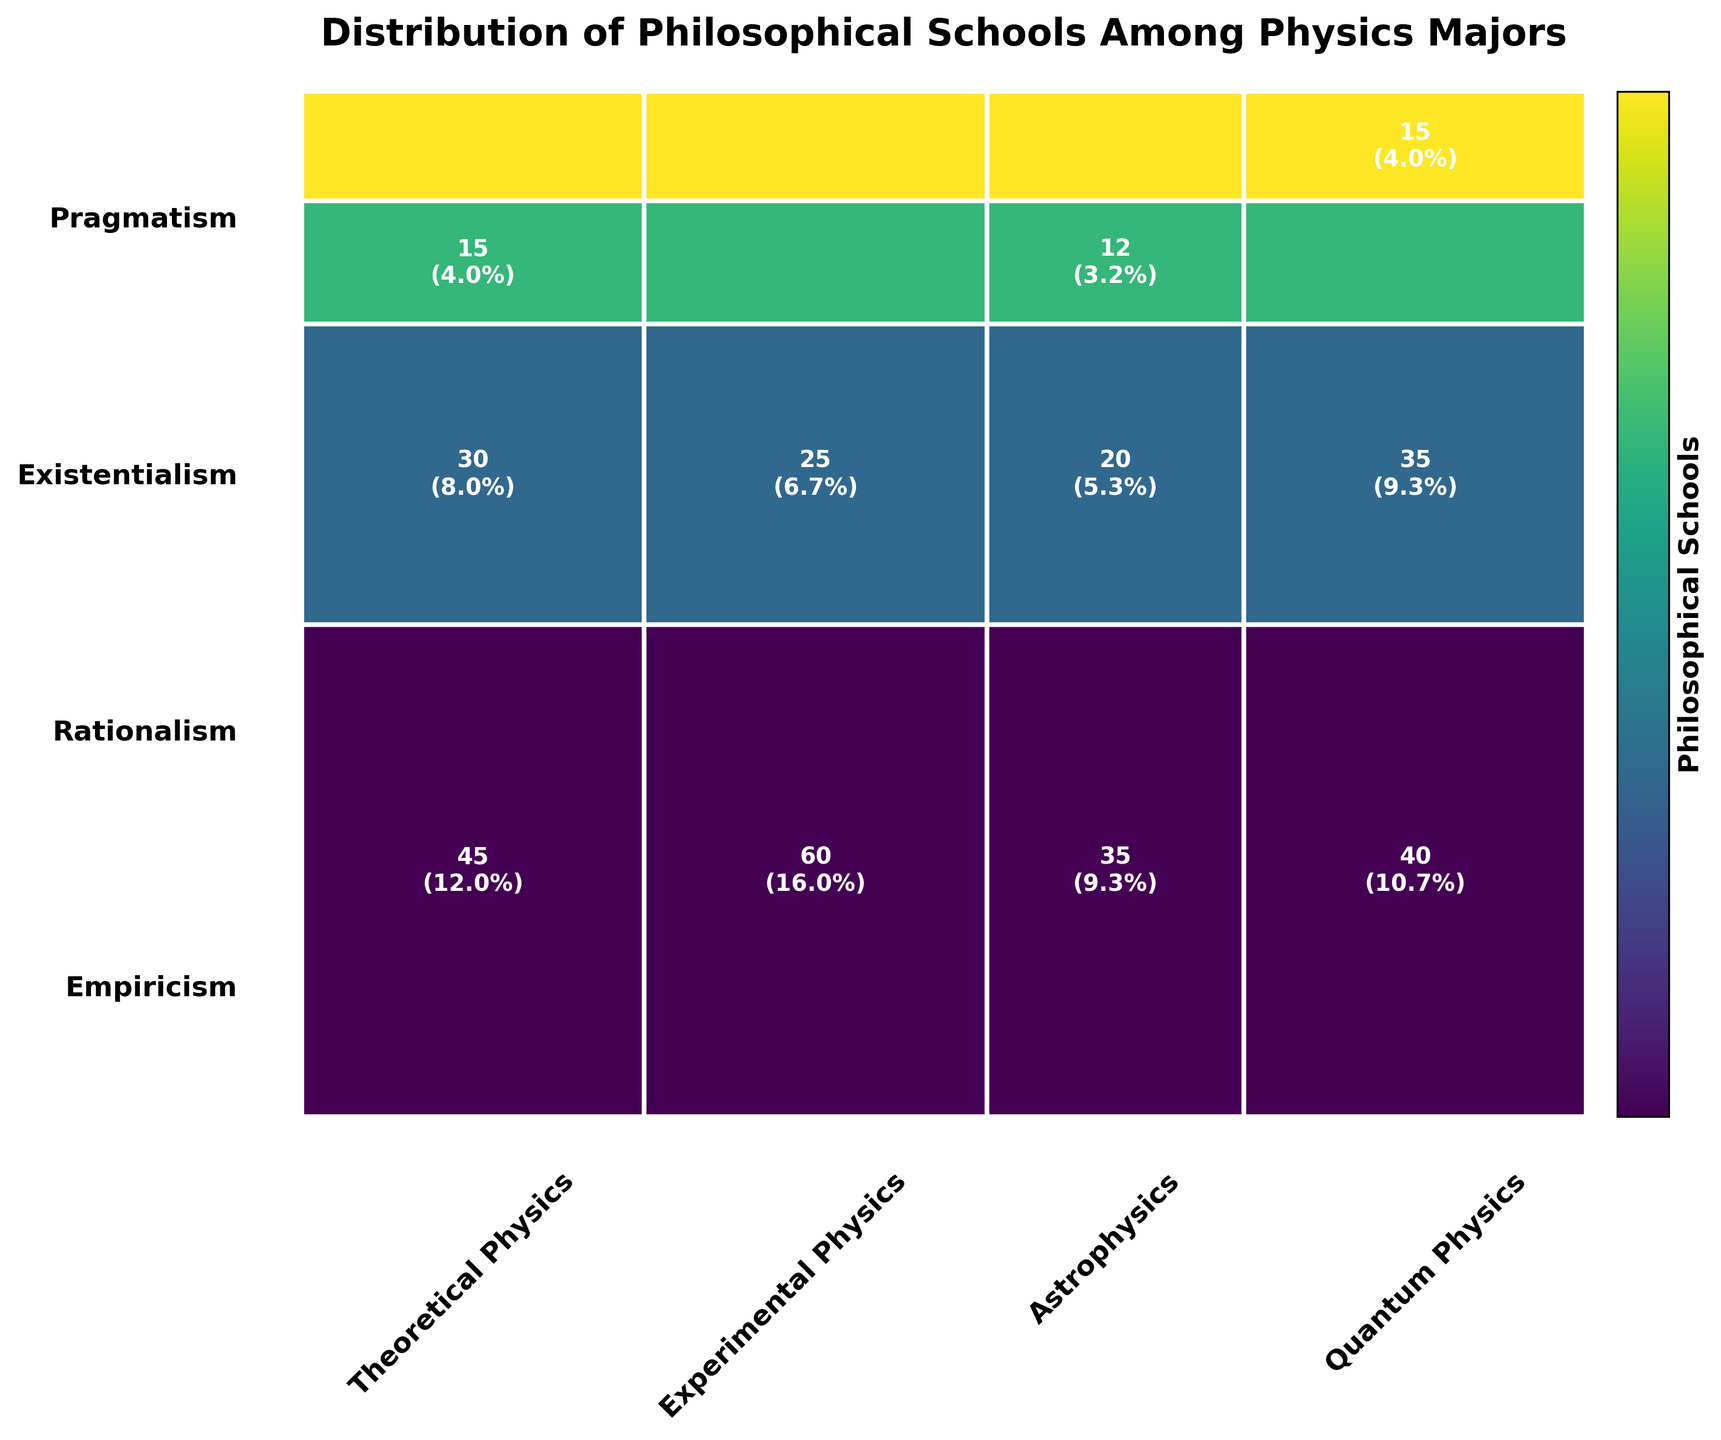What is the title of the figure? The title is usually displayed at the top of the figure. It provides a brief description of what the figure represents.
Answer: Distribution of Philosophical Schools Among Physics Majors Which philosophical school has the largest representation in Experimental Physics? By looking at the relative sizes of the rectangles for each school within the Experimental Physics category, the largest block corresponds to Empiricism.
Answer: Empiricism How many physics majors align with Rationalism? Sum the counts for Rationalism across all Physics_Major_Type categories. Rationalism=30+25+20+35.
Answer: 110 Which philosophical school is least represented among all physics majors? The least represented school will have the smallest height in the mosaic plot. Pragmatism has the smallest total area.
Answer: Pragmatism Between Theoretical Physics and Quantum Physics, which has a higher count for Empiricism? Compare the rectangle dimensions for Empiricism between Theoretical Physics and Quantum Physics. Empiricism in Theoretical Physics is 45, while in Quantum Physics it is 40.
Answer: Theoretical Physics What is the ratio of Empiricism to Existentialism among physics majors? Calculate the total count for Empiricism and Existentialism. Empiricism=45+60+35+40 and Existentialism=15+8+12+10. Then, ratio = (45+60+35+40)/(15+8+12+10).
Answer: 9:1 Which philosophical school has the most uniform distribution across the different physics major types? Examine the rectangles' relative proportions within each school, Rationalism has relatively similar sizes across all categories.
Answer: Rationalism Does Pragmatism have a higher count in Quantum Physics or Astrophysics? Compare the rectangle sizes for Pragmatism in Quantum Physics and Astrophysics. Pragmatism in Quantum Physics is 15, while in Astrophysics it is 8.
Answer: Quantum Physics Which combination of philosophical school and physics major type has the highest single count? Look for the largest rectangle within the mosaic plot, which belongs to Empiricism in Experimental Physics with count 60.
Answer: Empiricism and Experimental Physics What percentage of Theoretical Physics majors align with Existentialism? Divide the Existentialism count by the total Theoretical Physics count and multiply by 100. Existentialism=15 and total Theoretical Physics=45+30+15+10, percentage = (15/100)*100.
Answer: 15% 